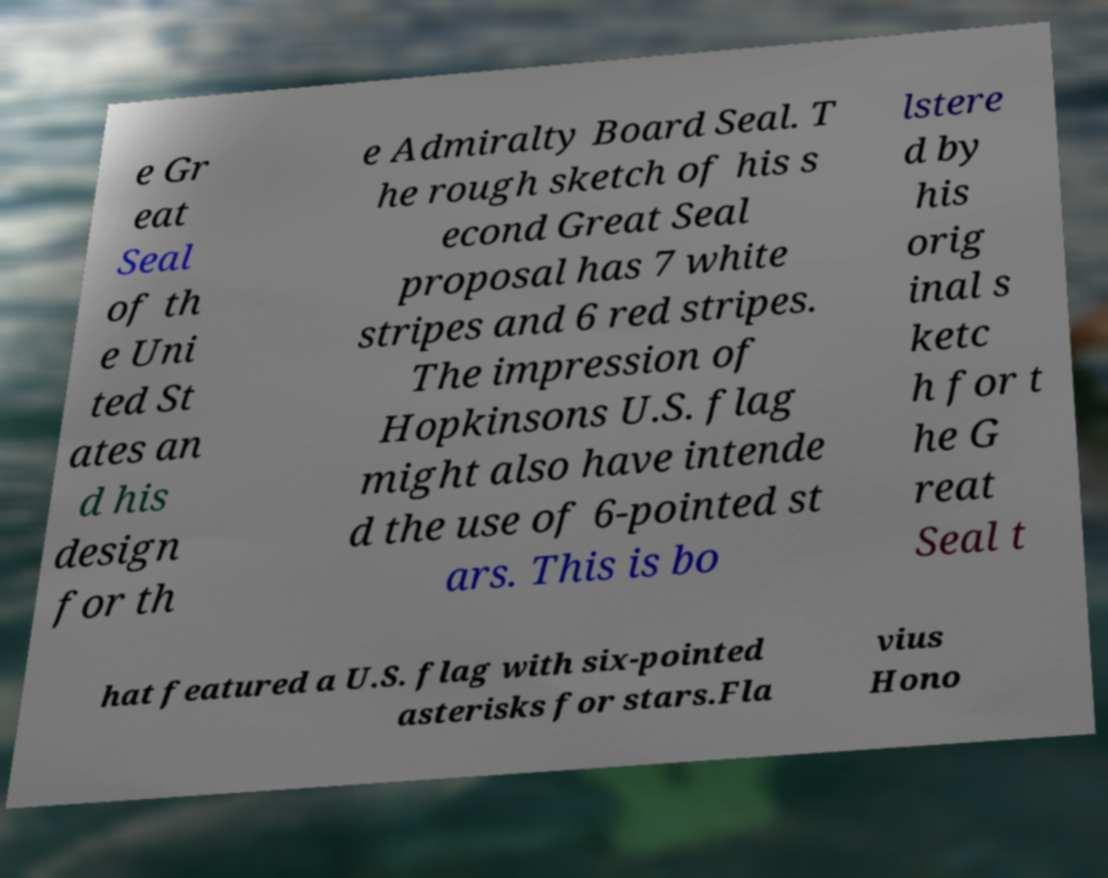Can you accurately transcribe the text from the provided image for me? e Gr eat Seal of th e Uni ted St ates an d his design for th e Admiralty Board Seal. T he rough sketch of his s econd Great Seal proposal has 7 white stripes and 6 red stripes. The impression of Hopkinsons U.S. flag might also have intende d the use of 6-pointed st ars. This is bo lstere d by his orig inal s ketc h for t he G reat Seal t hat featured a U.S. flag with six-pointed asterisks for stars.Fla vius Hono 